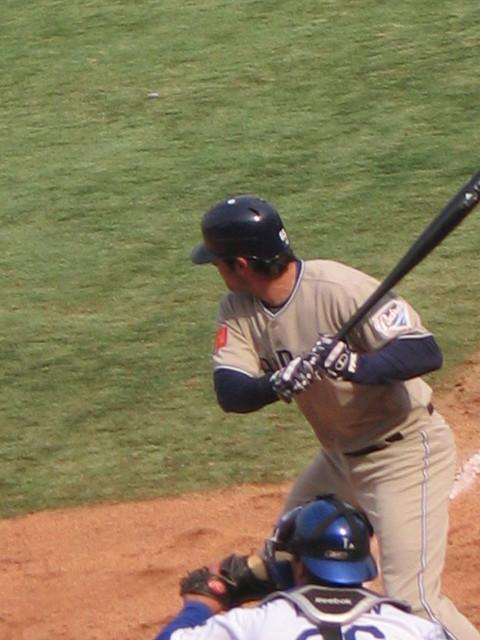Which hand is dominant in the batter shown?

Choices:
A) right
B) left
C) neither
D) ambidextrous left 